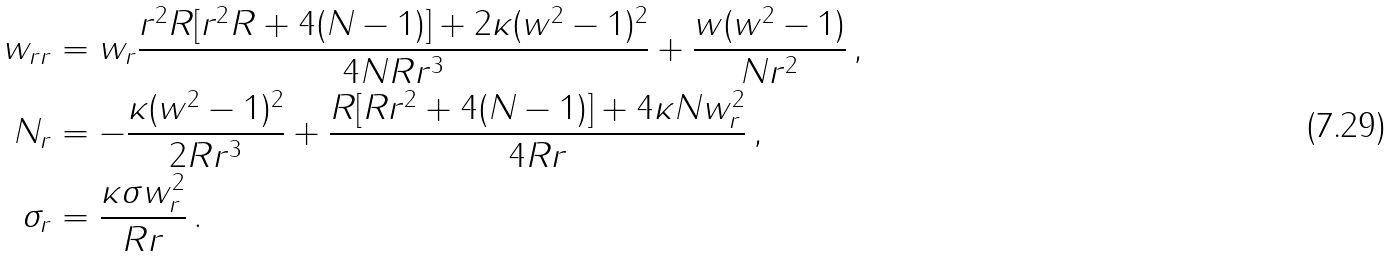Convert formula to latex. <formula><loc_0><loc_0><loc_500><loc_500>w _ { r r } & = w _ { r } \frac { r ^ { 2 } R [ r ^ { 2 } R + 4 ( N - 1 ) ] + 2 \kappa ( w ^ { 2 } - 1 ) ^ { 2 } } { 4 N R r ^ { 3 } } + \frac { w ( w ^ { 2 } - 1 ) } { N r ^ { 2 } } \, , \\ N _ { r } & = - \frac { \kappa ( w ^ { 2 } - 1 ) ^ { 2 } } { 2 R r ^ { 3 } } + \frac { R [ R r ^ { 2 } + 4 ( N - 1 ) ] + 4 \kappa N w _ { r } ^ { 2 } } { 4 R r } \, , \\ \sigma _ { r } & = \frac { \kappa \sigma w _ { r } ^ { 2 } } { R r } \, .</formula> 